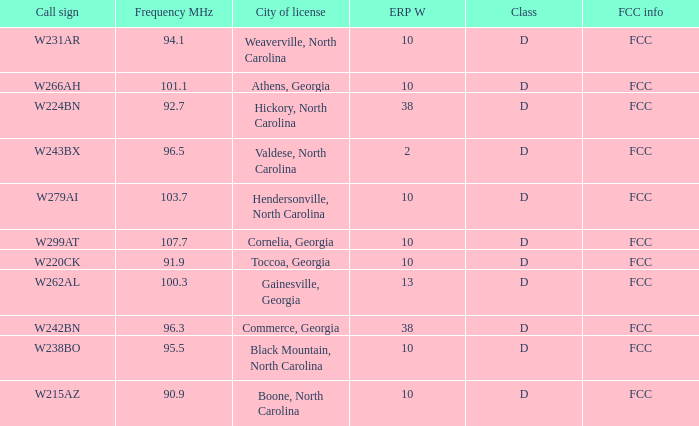What is the Frequency MHz for the station with a call sign of w224bn? 92.7. 